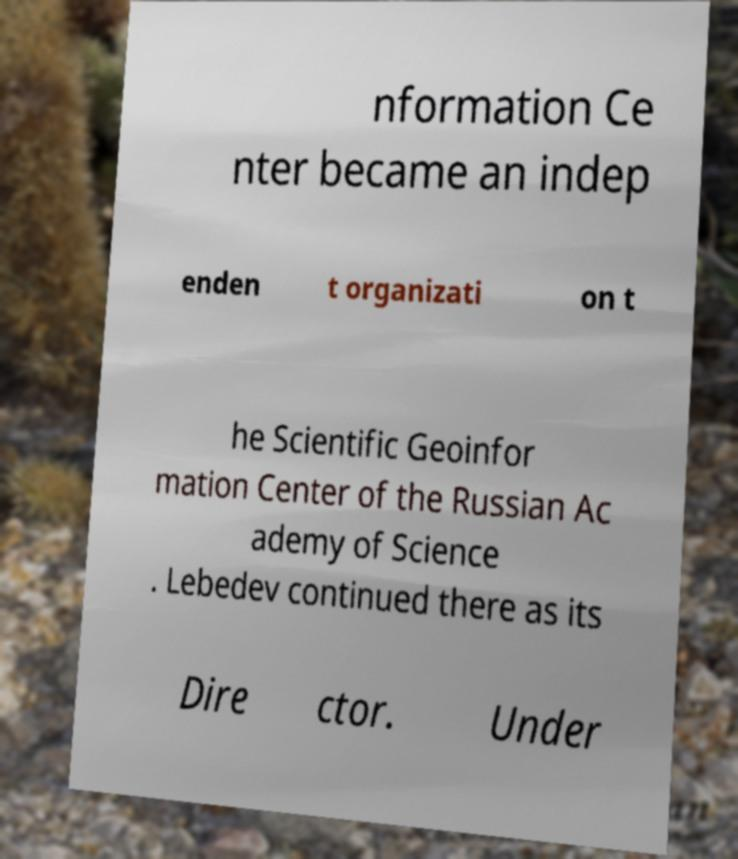Could you extract and type out the text from this image? nformation Ce nter became an indep enden t organizati on t he Scientific Geoinfor mation Center of the Russian Ac ademy of Science . Lebedev continued there as its Dire ctor. Under 